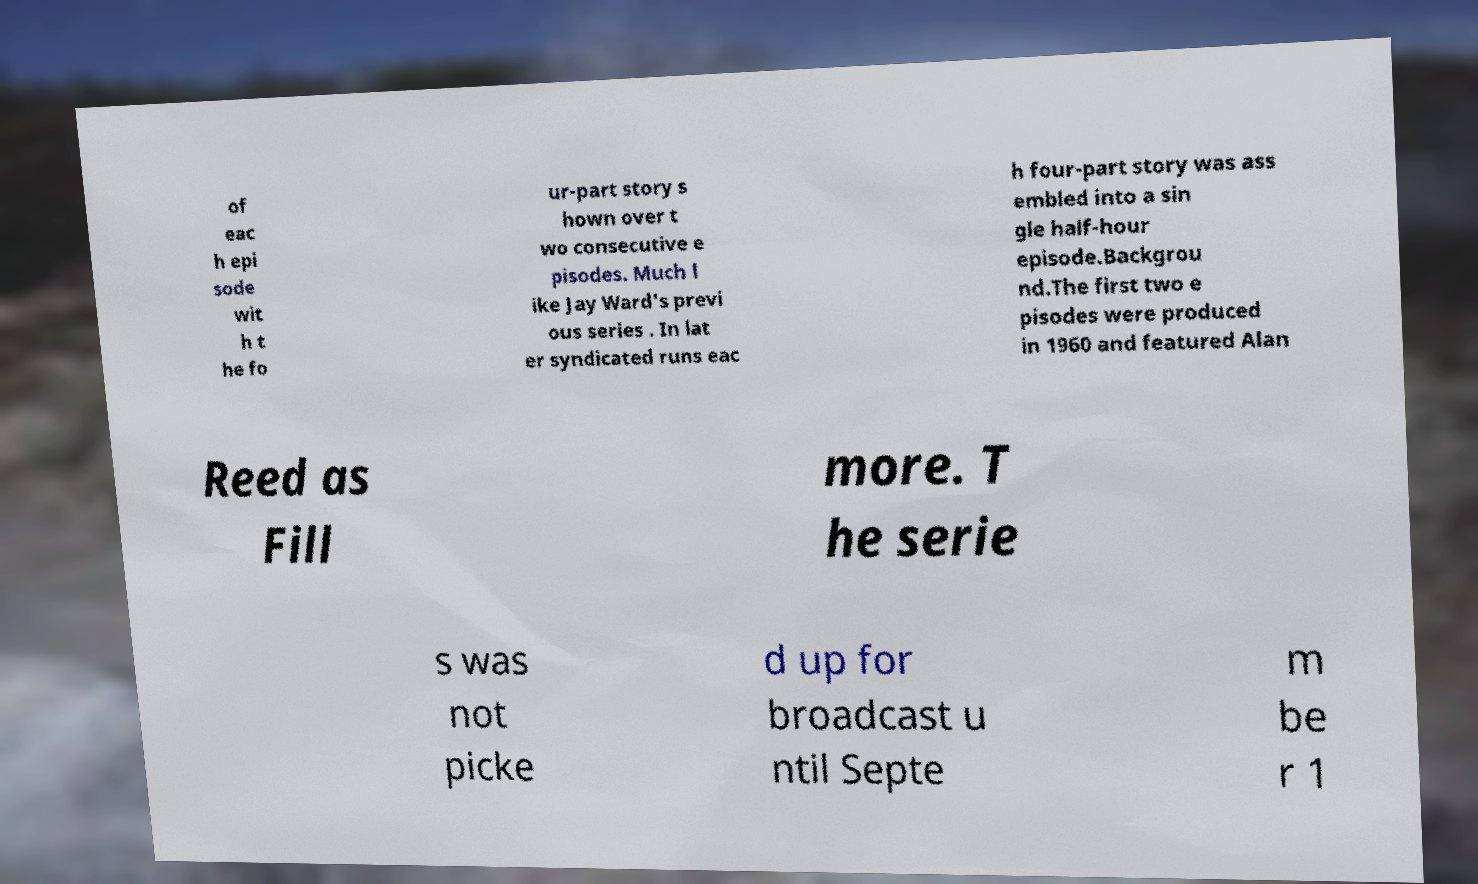Please read and relay the text visible in this image. What does it say? of eac h epi sode wit h t he fo ur-part story s hown over t wo consecutive e pisodes. Much l ike Jay Ward's previ ous series . In lat er syndicated runs eac h four-part story was ass embled into a sin gle half-hour episode.Backgrou nd.The first two e pisodes were produced in 1960 and featured Alan Reed as Fill more. T he serie s was not picke d up for broadcast u ntil Septe m be r 1 